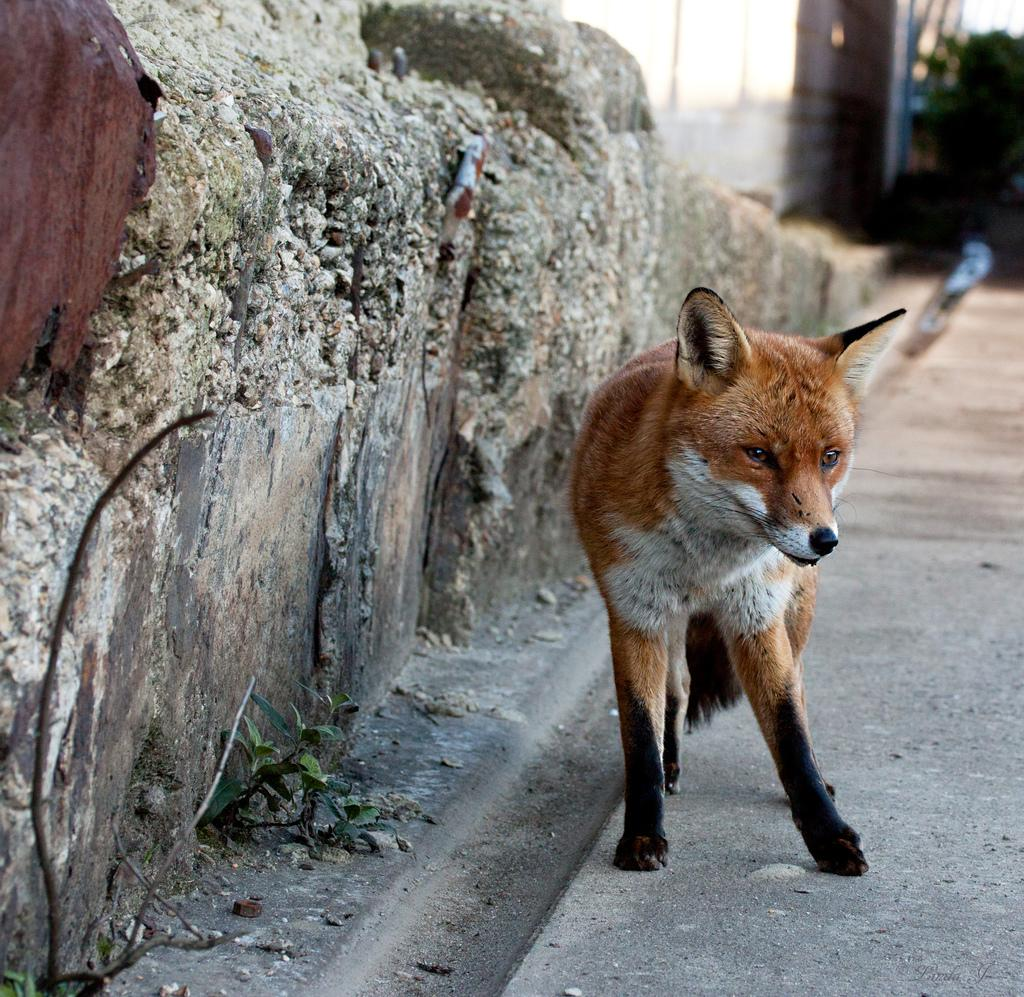What type of animal is in the image? There is an animal in the image, but its specific type cannot be determined from the provided facts. Can you describe the color pattern of the animal? The animal has brown and white colors. What structure is visible in the image? There is a wall visible in the image. How would you describe the background of the image? The background of the image is blurred. What subject is the animal teaching in the image? There is no indication in the image that the animal is teaching a subject. Can you tell me how many deer are present in the image? There is no mention of deer in the image, so it is impossible to determine their presence or quantity. 